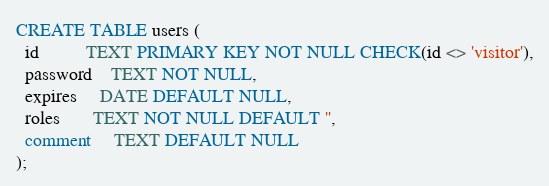Convert code to text. <code><loc_0><loc_0><loc_500><loc_500><_SQL_>CREATE TABLE users (
  id          TEXT PRIMARY KEY NOT NULL CHECK(id <> 'visitor'),
  password    TEXT NOT NULL,
  expires     DATE DEFAULT NULL,
  roles       TEXT NOT NULL DEFAULT '',
  comment     TEXT DEFAULT NULL
);

</code> 